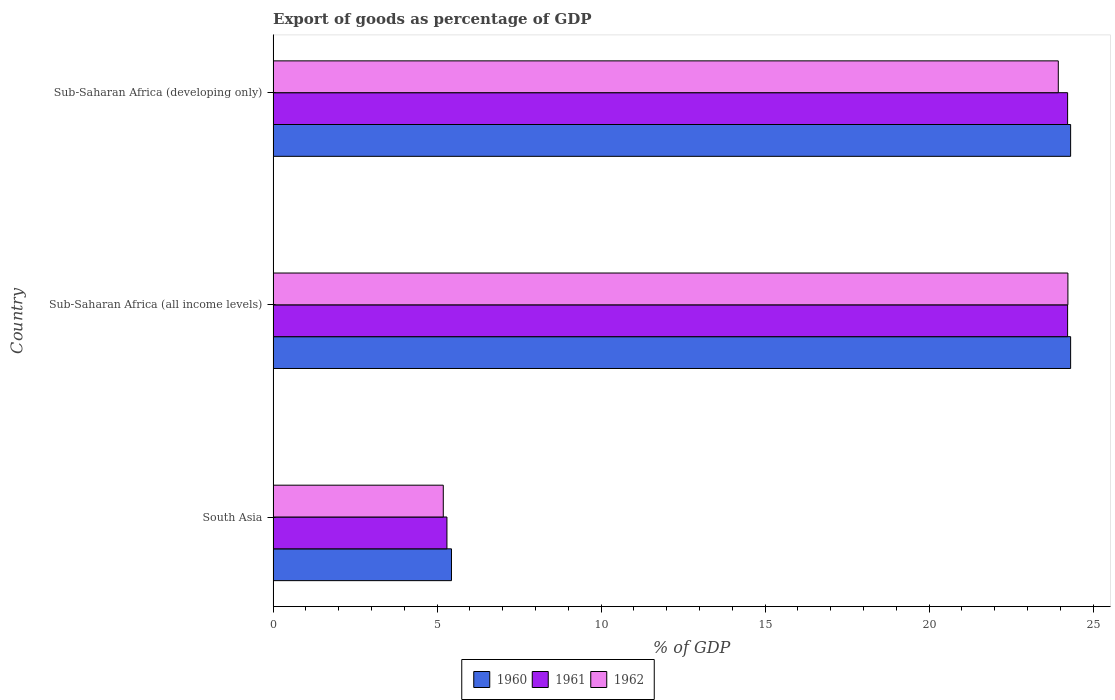How many different coloured bars are there?
Make the answer very short. 3. How many groups of bars are there?
Your response must be concise. 3. Are the number of bars per tick equal to the number of legend labels?
Provide a succinct answer. Yes. Are the number of bars on each tick of the Y-axis equal?
Make the answer very short. Yes. What is the label of the 2nd group of bars from the top?
Give a very brief answer. Sub-Saharan Africa (all income levels). What is the export of goods as percentage of GDP in 1960 in Sub-Saharan Africa (all income levels)?
Offer a terse response. 24.31. Across all countries, what is the maximum export of goods as percentage of GDP in 1961?
Give a very brief answer. 24.22. Across all countries, what is the minimum export of goods as percentage of GDP in 1961?
Ensure brevity in your answer.  5.3. In which country was the export of goods as percentage of GDP in 1961 maximum?
Provide a succinct answer. Sub-Saharan Africa (all income levels). What is the total export of goods as percentage of GDP in 1960 in the graph?
Offer a terse response. 54.07. What is the difference between the export of goods as percentage of GDP in 1961 in Sub-Saharan Africa (developing only) and the export of goods as percentage of GDP in 1962 in Sub-Saharan Africa (all income levels)?
Offer a very short reply. -0.01. What is the average export of goods as percentage of GDP in 1962 per country?
Your answer should be compact. 17.79. What is the difference between the export of goods as percentage of GDP in 1960 and export of goods as percentage of GDP in 1961 in Sub-Saharan Africa (all income levels)?
Offer a very short reply. 0.09. In how many countries, is the export of goods as percentage of GDP in 1960 greater than 17 %?
Provide a succinct answer. 2. What is the ratio of the export of goods as percentage of GDP in 1961 in South Asia to that in Sub-Saharan Africa (all income levels)?
Make the answer very short. 0.22. What is the difference between the highest and the second highest export of goods as percentage of GDP in 1960?
Provide a short and direct response. 0. What is the difference between the highest and the lowest export of goods as percentage of GDP in 1960?
Offer a terse response. 18.88. What does the 1st bar from the top in Sub-Saharan Africa (all income levels) represents?
Offer a very short reply. 1962. Is it the case that in every country, the sum of the export of goods as percentage of GDP in 1962 and export of goods as percentage of GDP in 1961 is greater than the export of goods as percentage of GDP in 1960?
Offer a very short reply. Yes. How are the legend labels stacked?
Provide a short and direct response. Horizontal. What is the title of the graph?
Provide a succinct answer. Export of goods as percentage of GDP. Does "2010" appear as one of the legend labels in the graph?
Offer a terse response. No. What is the label or title of the X-axis?
Offer a very short reply. % of GDP. What is the % of GDP of 1960 in South Asia?
Ensure brevity in your answer.  5.44. What is the % of GDP in 1961 in South Asia?
Ensure brevity in your answer.  5.3. What is the % of GDP in 1962 in South Asia?
Offer a very short reply. 5.19. What is the % of GDP of 1960 in Sub-Saharan Africa (all income levels)?
Your response must be concise. 24.31. What is the % of GDP in 1961 in Sub-Saharan Africa (all income levels)?
Make the answer very short. 24.22. What is the % of GDP of 1962 in Sub-Saharan Africa (all income levels)?
Provide a short and direct response. 24.23. What is the % of GDP of 1960 in Sub-Saharan Africa (developing only)?
Provide a short and direct response. 24.31. What is the % of GDP of 1961 in Sub-Saharan Africa (developing only)?
Give a very brief answer. 24.22. What is the % of GDP of 1962 in Sub-Saharan Africa (developing only)?
Provide a short and direct response. 23.94. Across all countries, what is the maximum % of GDP in 1960?
Offer a very short reply. 24.31. Across all countries, what is the maximum % of GDP in 1961?
Offer a very short reply. 24.22. Across all countries, what is the maximum % of GDP in 1962?
Give a very brief answer. 24.23. Across all countries, what is the minimum % of GDP of 1960?
Make the answer very short. 5.44. Across all countries, what is the minimum % of GDP in 1961?
Your response must be concise. 5.3. Across all countries, what is the minimum % of GDP of 1962?
Provide a short and direct response. 5.19. What is the total % of GDP of 1960 in the graph?
Give a very brief answer. 54.07. What is the total % of GDP of 1961 in the graph?
Ensure brevity in your answer.  53.74. What is the total % of GDP of 1962 in the graph?
Provide a succinct answer. 53.36. What is the difference between the % of GDP in 1960 in South Asia and that in Sub-Saharan Africa (all income levels)?
Offer a terse response. -18.88. What is the difference between the % of GDP in 1961 in South Asia and that in Sub-Saharan Africa (all income levels)?
Offer a very short reply. -18.92. What is the difference between the % of GDP in 1962 in South Asia and that in Sub-Saharan Africa (all income levels)?
Keep it short and to the point. -19.04. What is the difference between the % of GDP of 1960 in South Asia and that in Sub-Saharan Africa (developing only)?
Offer a very short reply. -18.88. What is the difference between the % of GDP of 1961 in South Asia and that in Sub-Saharan Africa (developing only)?
Provide a short and direct response. -18.92. What is the difference between the % of GDP in 1962 in South Asia and that in Sub-Saharan Africa (developing only)?
Offer a terse response. -18.75. What is the difference between the % of GDP of 1960 in Sub-Saharan Africa (all income levels) and that in Sub-Saharan Africa (developing only)?
Give a very brief answer. 0. What is the difference between the % of GDP in 1961 in Sub-Saharan Africa (all income levels) and that in Sub-Saharan Africa (developing only)?
Keep it short and to the point. 0. What is the difference between the % of GDP in 1962 in Sub-Saharan Africa (all income levels) and that in Sub-Saharan Africa (developing only)?
Offer a terse response. 0.29. What is the difference between the % of GDP of 1960 in South Asia and the % of GDP of 1961 in Sub-Saharan Africa (all income levels)?
Give a very brief answer. -18.79. What is the difference between the % of GDP in 1960 in South Asia and the % of GDP in 1962 in Sub-Saharan Africa (all income levels)?
Make the answer very short. -18.79. What is the difference between the % of GDP in 1961 in South Asia and the % of GDP in 1962 in Sub-Saharan Africa (all income levels)?
Your answer should be very brief. -18.93. What is the difference between the % of GDP in 1960 in South Asia and the % of GDP in 1961 in Sub-Saharan Africa (developing only)?
Provide a short and direct response. -18.79. What is the difference between the % of GDP in 1960 in South Asia and the % of GDP in 1962 in Sub-Saharan Africa (developing only)?
Offer a terse response. -18.5. What is the difference between the % of GDP in 1961 in South Asia and the % of GDP in 1962 in Sub-Saharan Africa (developing only)?
Your response must be concise. -18.64. What is the difference between the % of GDP of 1960 in Sub-Saharan Africa (all income levels) and the % of GDP of 1961 in Sub-Saharan Africa (developing only)?
Give a very brief answer. 0.09. What is the difference between the % of GDP in 1960 in Sub-Saharan Africa (all income levels) and the % of GDP in 1962 in Sub-Saharan Africa (developing only)?
Offer a very short reply. 0.38. What is the difference between the % of GDP in 1961 in Sub-Saharan Africa (all income levels) and the % of GDP in 1962 in Sub-Saharan Africa (developing only)?
Your response must be concise. 0.28. What is the average % of GDP in 1960 per country?
Your answer should be very brief. 18.02. What is the average % of GDP in 1961 per country?
Offer a very short reply. 17.91. What is the average % of GDP in 1962 per country?
Make the answer very short. 17.79. What is the difference between the % of GDP in 1960 and % of GDP in 1961 in South Asia?
Give a very brief answer. 0.14. What is the difference between the % of GDP in 1960 and % of GDP in 1962 in South Asia?
Your answer should be very brief. 0.25. What is the difference between the % of GDP of 1961 and % of GDP of 1962 in South Asia?
Provide a short and direct response. 0.11. What is the difference between the % of GDP in 1960 and % of GDP in 1961 in Sub-Saharan Africa (all income levels)?
Offer a very short reply. 0.09. What is the difference between the % of GDP in 1960 and % of GDP in 1962 in Sub-Saharan Africa (all income levels)?
Provide a short and direct response. 0.08. What is the difference between the % of GDP of 1961 and % of GDP of 1962 in Sub-Saharan Africa (all income levels)?
Your answer should be very brief. -0.01. What is the difference between the % of GDP of 1960 and % of GDP of 1961 in Sub-Saharan Africa (developing only)?
Your answer should be compact. 0.09. What is the difference between the % of GDP of 1960 and % of GDP of 1962 in Sub-Saharan Africa (developing only)?
Keep it short and to the point. 0.38. What is the difference between the % of GDP in 1961 and % of GDP in 1962 in Sub-Saharan Africa (developing only)?
Ensure brevity in your answer.  0.28. What is the ratio of the % of GDP of 1960 in South Asia to that in Sub-Saharan Africa (all income levels)?
Offer a very short reply. 0.22. What is the ratio of the % of GDP of 1961 in South Asia to that in Sub-Saharan Africa (all income levels)?
Provide a short and direct response. 0.22. What is the ratio of the % of GDP in 1962 in South Asia to that in Sub-Saharan Africa (all income levels)?
Your response must be concise. 0.21. What is the ratio of the % of GDP of 1960 in South Asia to that in Sub-Saharan Africa (developing only)?
Offer a very short reply. 0.22. What is the ratio of the % of GDP in 1961 in South Asia to that in Sub-Saharan Africa (developing only)?
Give a very brief answer. 0.22. What is the ratio of the % of GDP of 1962 in South Asia to that in Sub-Saharan Africa (developing only)?
Your response must be concise. 0.22. What is the ratio of the % of GDP of 1960 in Sub-Saharan Africa (all income levels) to that in Sub-Saharan Africa (developing only)?
Make the answer very short. 1. What is the ratio of the % of GDP of 1962 in Sub-Saharan Africa (all income levels) to that in Sub-Saharan Africa (developing only)?
Offer a terse response. 1.01. What is the difference between the highest and the second highest % of GDP of 1960?
Your response must be concise. 0. What is the difference between the highest and the second highest % of GDP in 1961?
Provide a succinct answer. 0. What is the difference between the highest and the second highest % of GDP of 1962?
Keep it short and to the point. 0.29. What is the difference between the highest and the lowest % of GDP in 1960?
Give a very brief answer. 18.88. What is the difference between the highest and the lowest % of GDP in 1961?
Your response must be concise. 18.92. What is the difference between the highest and the lowest % of GDP of 1962?
Ensure brevity in your answer.  19.04. 